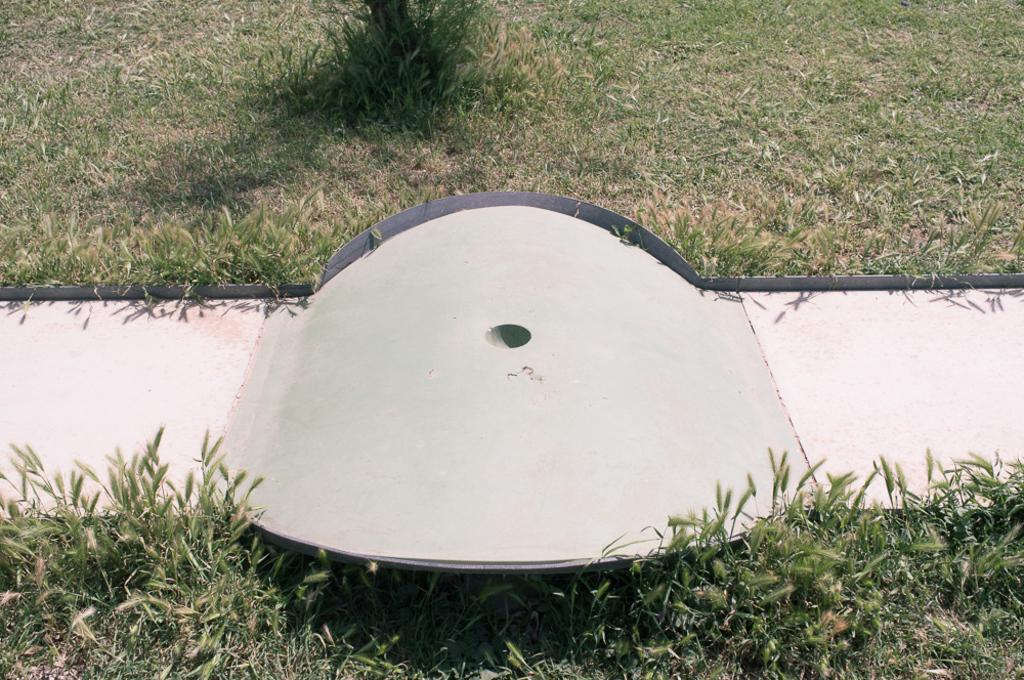What type of surface covers the ground in the image? The ground in the image is covered with grass. What feature is present in the middle of the image? There is a path in the middle of the image. Can you describe the path in more detail? The path has a ramp. Where can the chicken be seen crossing the wire in the image? There is no chicken or wire present in the image. What type of path is visible in the image, other than the grass-covered path? There is no other path visible in the image besides the grass-covered path with a ramp. 